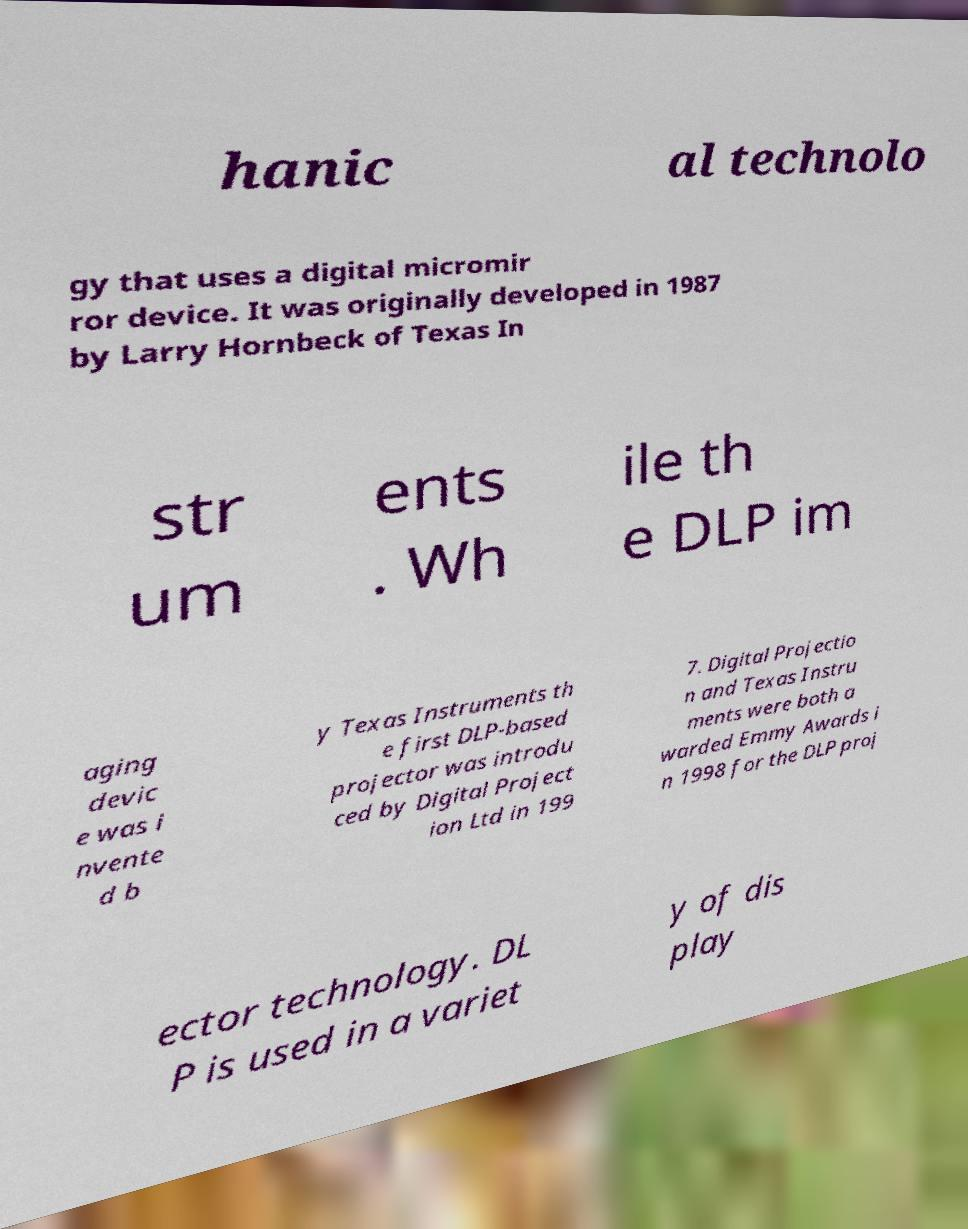There's text embedded in this image that I need extracted. Can you transcribe it verbatim? hanic al technolo gy that uses a digital micromir ror device. It was originally developed in 1987 by Larry Hornbeck of Texas In str um ents . Wh ile th e DLP im aging devic e was i nvente d b y Texas Instruments th e first DLP-based projector was introdu ced by Digital Project ion Ltd in 199 7. Digital Projectio n and Texas Instru ments were both a warded Emmy Awards i n 1998 for the DLP proj ector technology. DL P is used in a variet y of dis play 